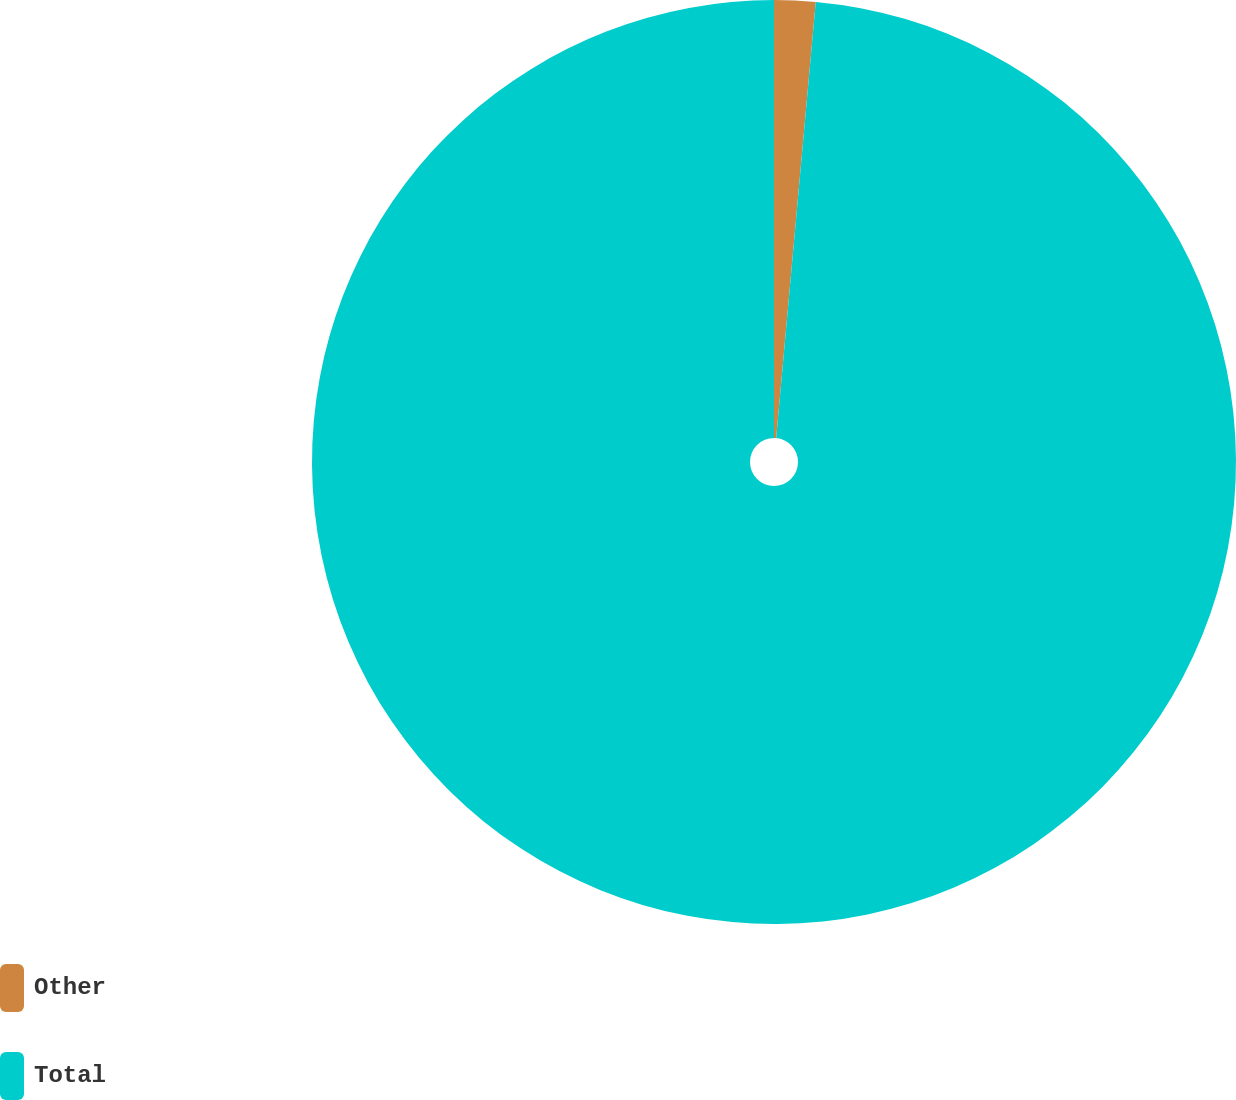Convert chart. <chart><loc_0><loc_0><loc_500><loc_500><pie_chart><fcel>Other<fcel>Total<nl><fcel>1.44%<fcel>98.56%<nl></chart> 